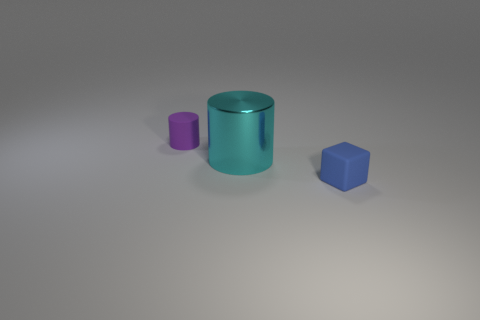Do the purple object and the big object that is on the left side of the small blue matte block have the same shape?
Make the answer very short. Yes. What is the material of the blue cube?
Make the answer very short. Rubber. There is another object that is the same shape as the large shiny thing; what is its size?
Provide a short and direct response. Small. What number of other objects are there of the same material as the blue thing?
Give a very brief answer. 1. Does the blue thing have the same material as the tiny thing that is on the left side of the blue rubber object?
Provide a short and direct response. Yes. Is the number of tiny cylinders to the right of the large cyan cylinder less than the number of blue matte things that are behind the blue object?
Ensure brevity in your answer.  No. What color is the cylinder to the left of the metallic cylinder?
Your response must be concise. Purple. What number of other things are the same color as the tiny block?
Ensure brevity in your answer.  0. There is a cylinder that is behind the cyan object; does it have the same size as the small blue rubber object?
Give a very brief answer. Yes. There is a blue rubber block; how many cyan things are behind it?
Keep it short and to the point. 1. 